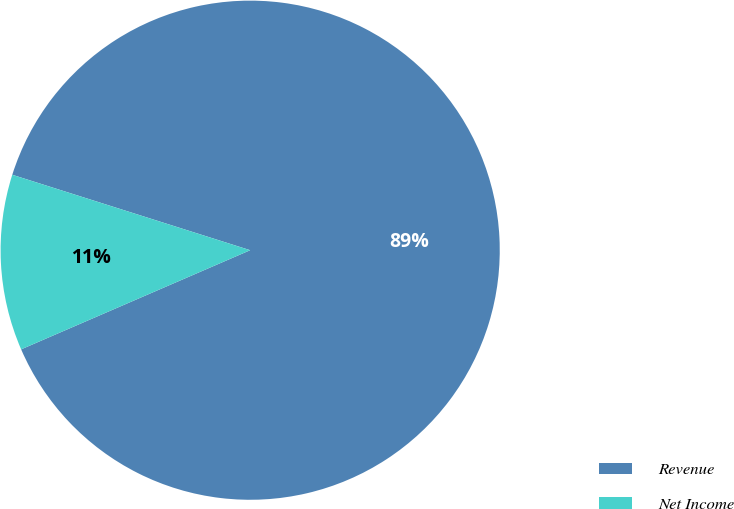Convert chart. <chart><loc_0><loc_0><loc_500><loc_500><pie_chart><fcel>Revenue<fcel>Net Income<nl><fcel>88.61%<fcel>11.39%<nl></chart> 